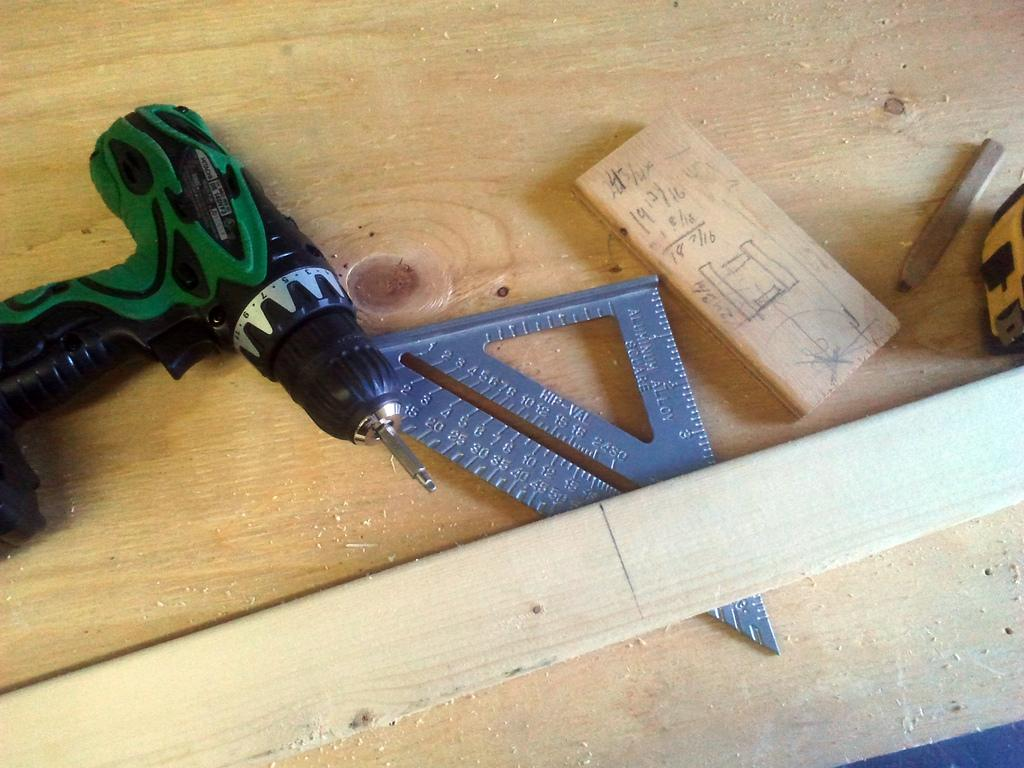<image>
Share a concise interpretation of the image provided. A cordless drill, other tools, and a wooden plank on a table and measurements being recorded in sixteens. 